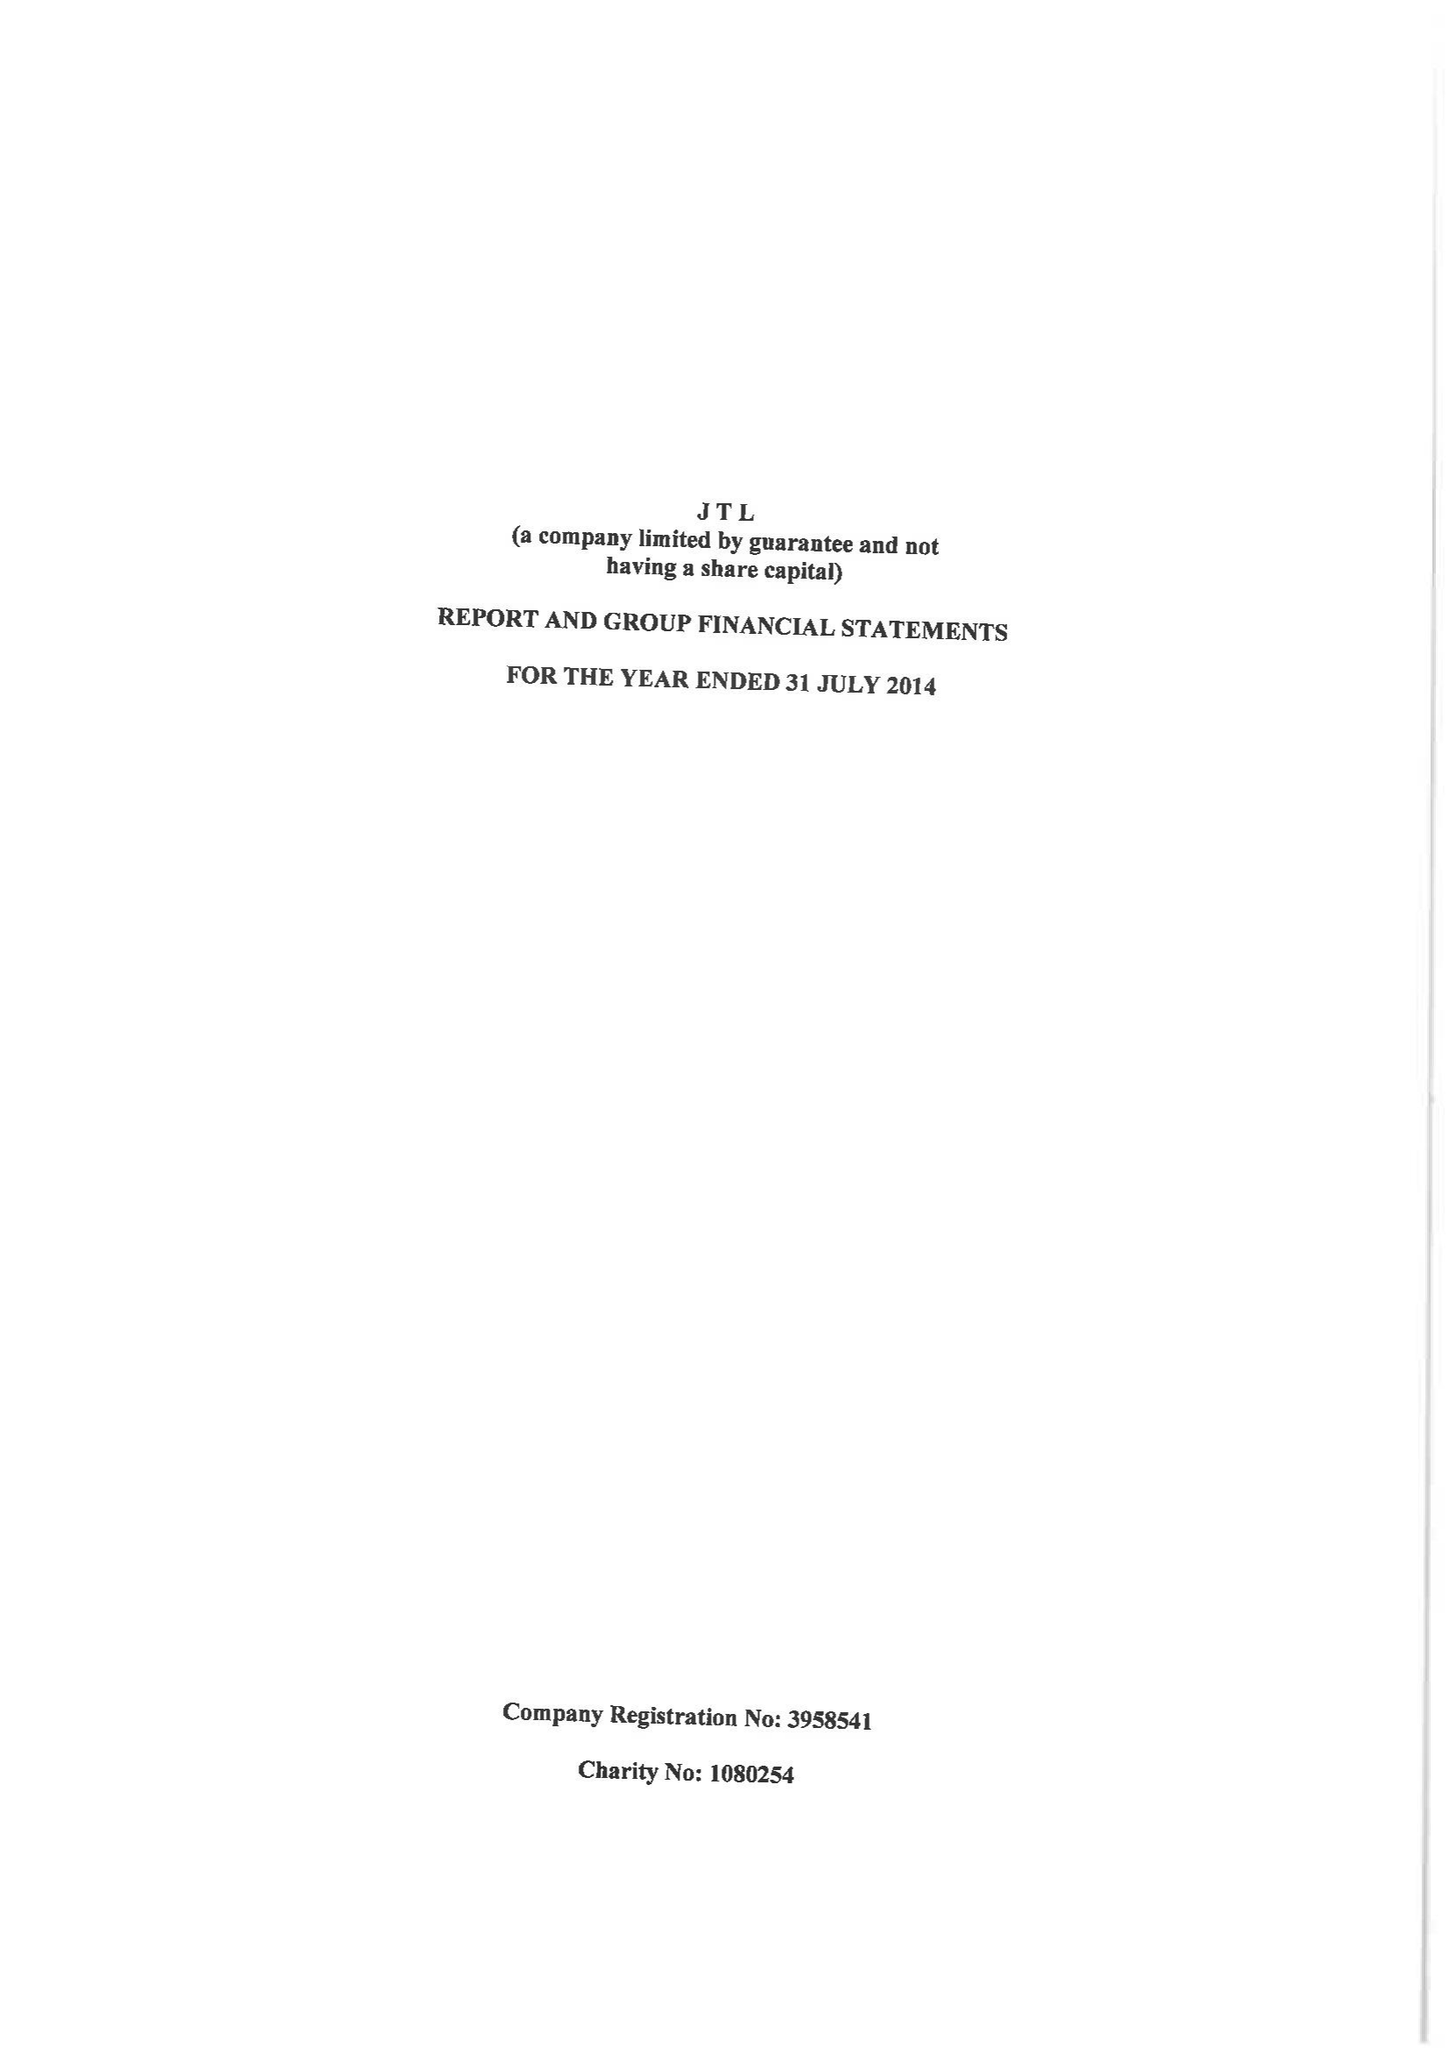What is the value for the charity_name?
Answer the question using a single word or phrase. Jtl 